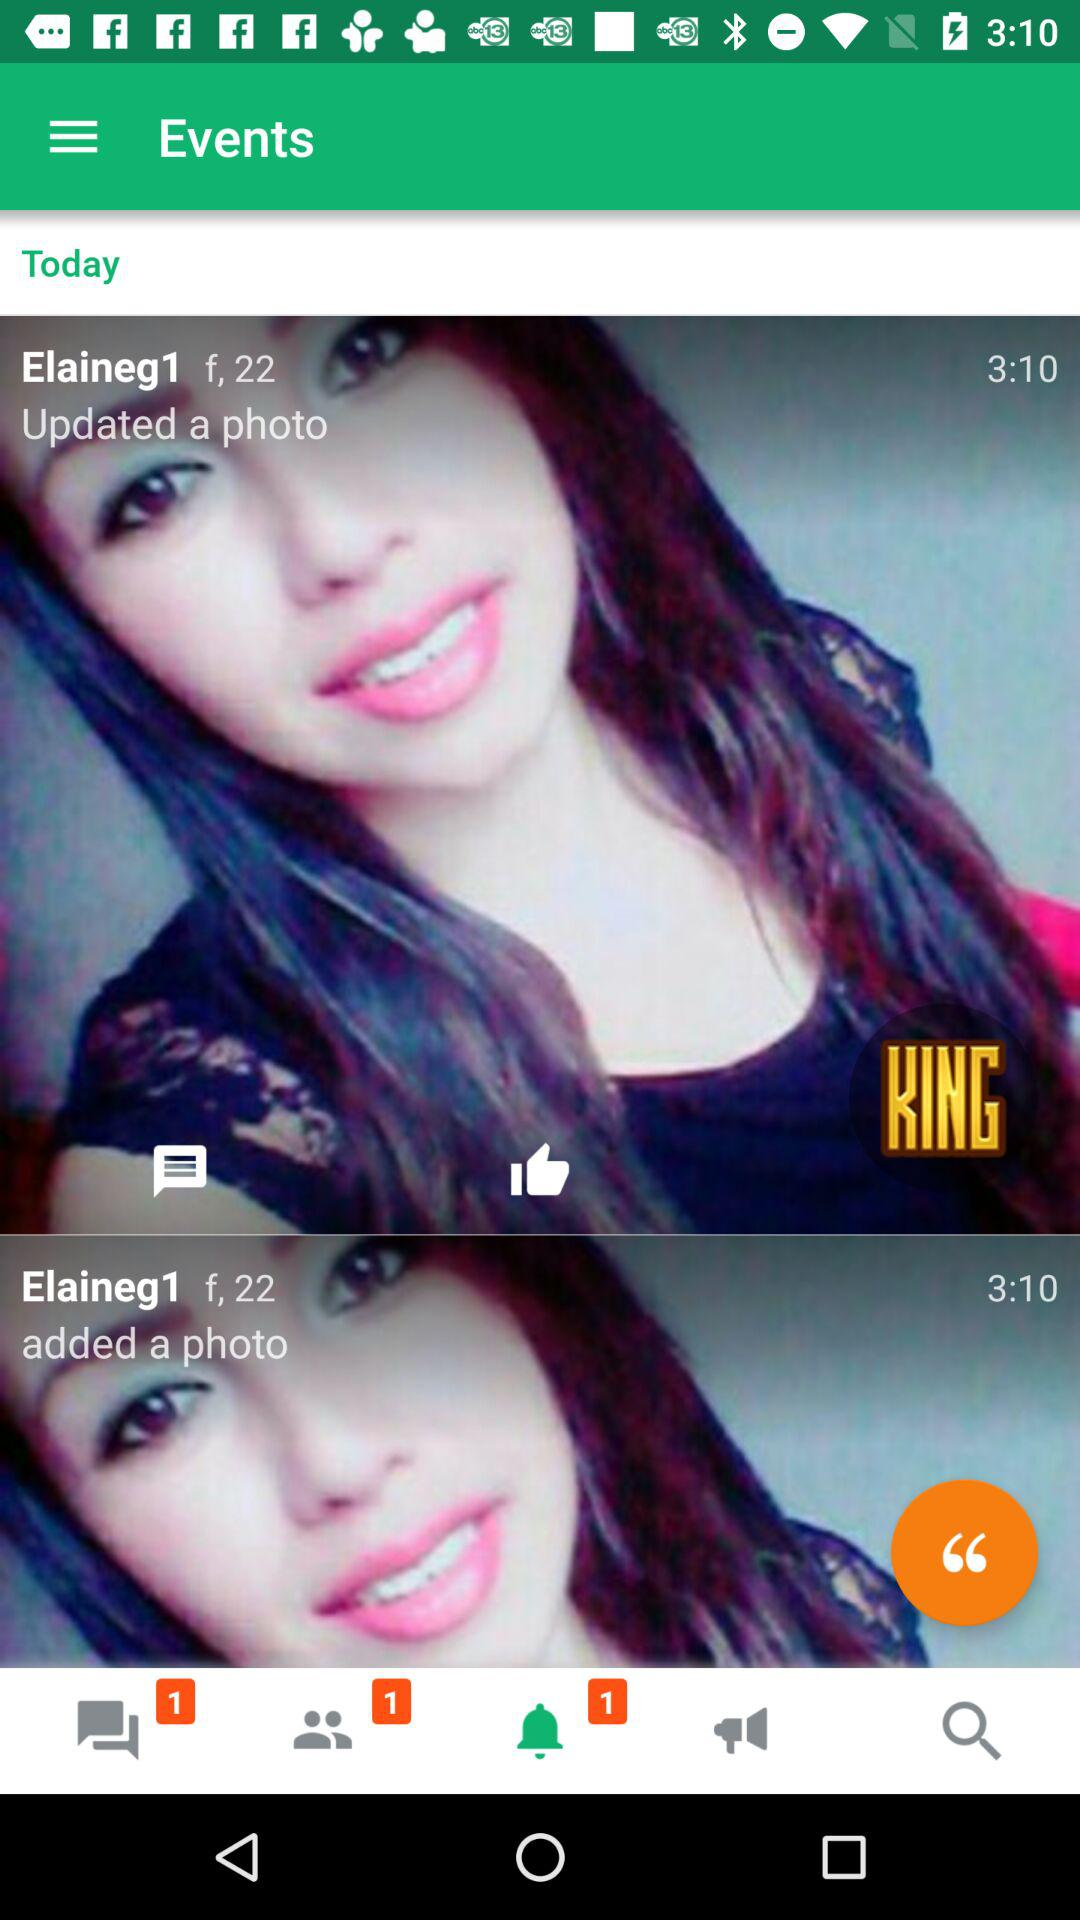What is the age of "Elaineg1"? The age of "Elaineg1" is 22. 